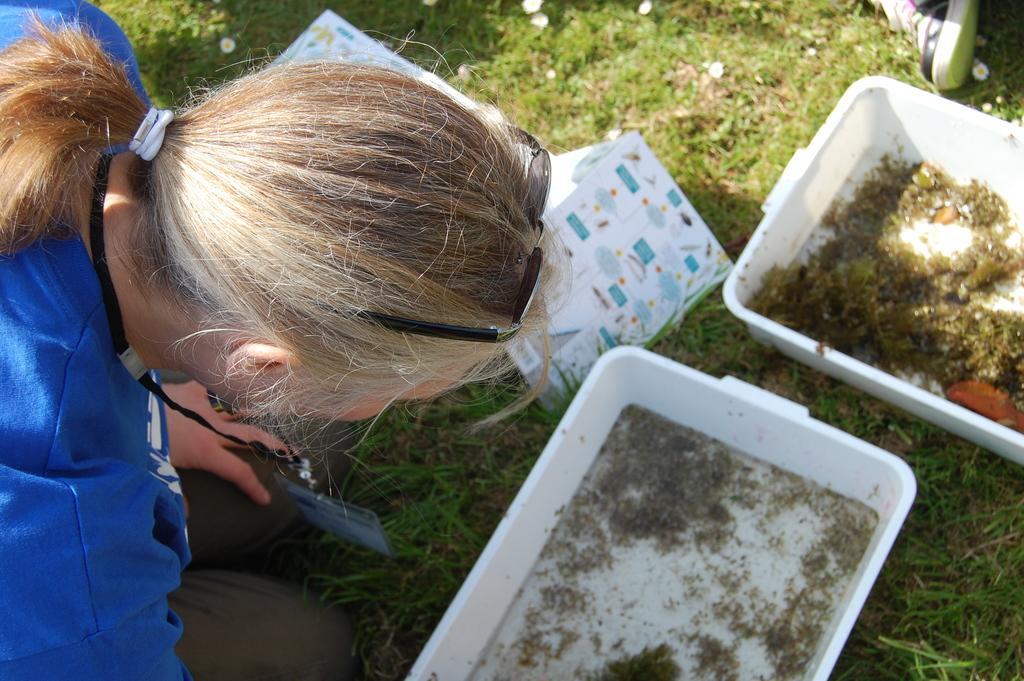Could you give a brief overview of what you see in this image? In this image I can see a person wearing blue shirt, brown pant. In front I can see two trays in white color and the grass is in green color. 